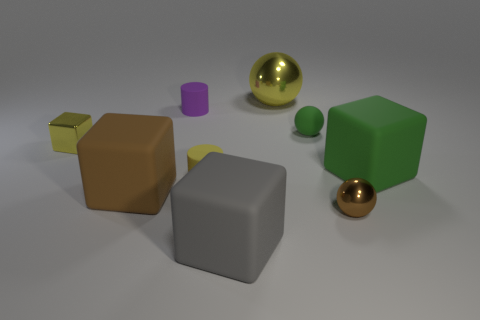Subtract 1 blocks. How many blocks are left? 3 Subtract all cylinders. How many objects are left? 7 Subtract all big green balls. Subtract all brown objects. How many objects are left? 7 Add 2 small green balls. How many small green balls are left? 3 Add 6 brown cylinders. How many brown cylinders exist? 6 Subtract 1 yellow cubes. How many objects are left? 8 